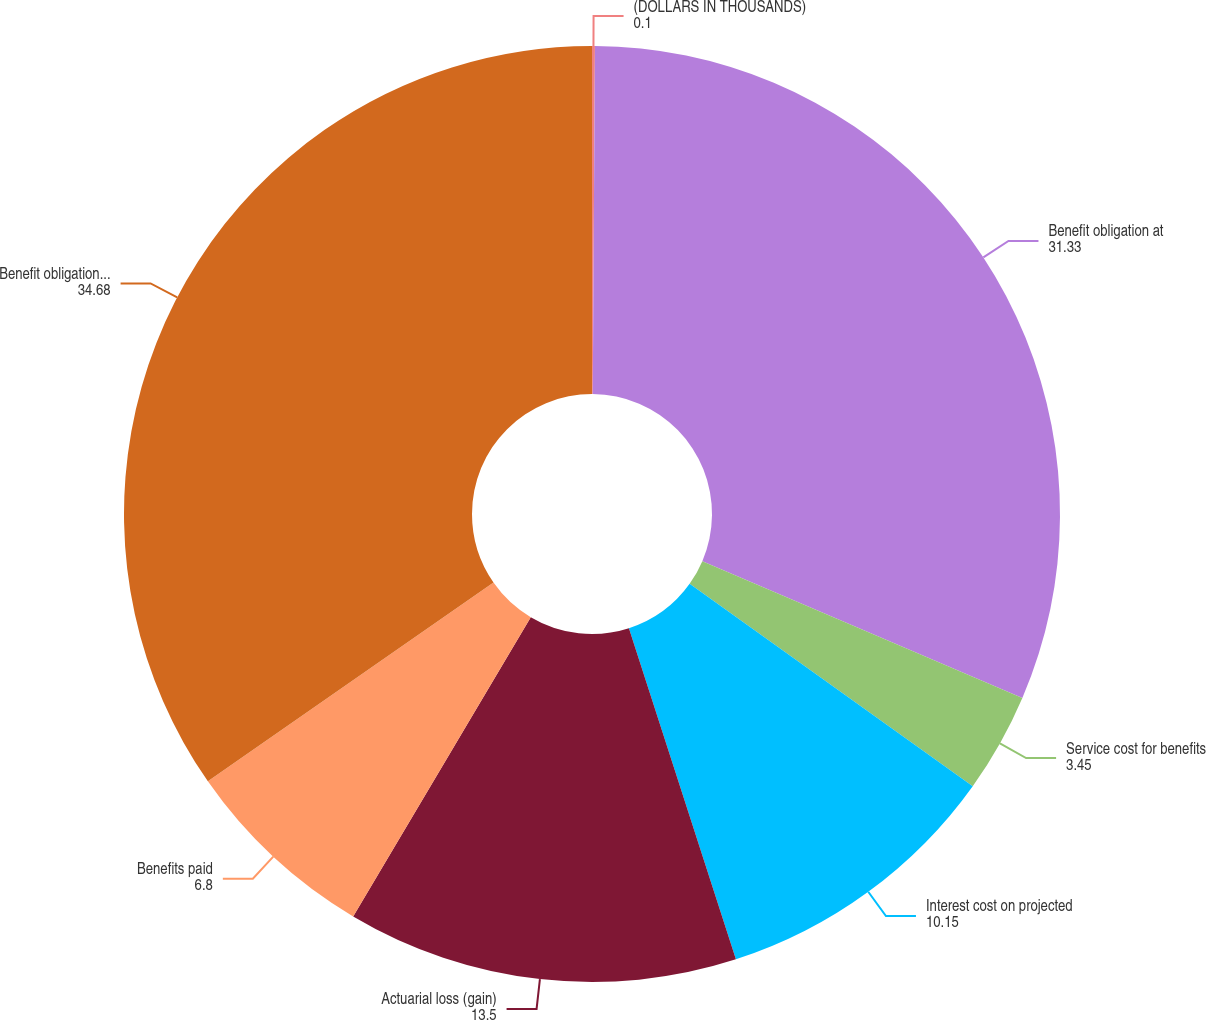<chart> <loc_0><loc_0><loc_500><loc_500><pie_chart><fcel>(DOLLARS IN THOUSANDS)<fcel>Benefit obligation at<fcel>Service cost for benefits<fcel>Interest cost on projected<fcel>Actuarial loss (gain)<fcel>Benefits paid<fcel>Benefit obligation at end of<nl><fcel>0.1%<fcel>31.33%<fcel>3.45%<fcel>10.15%<fcel>13.5%<fcel>6.8%<fcel>34.68%<nl></chart> 